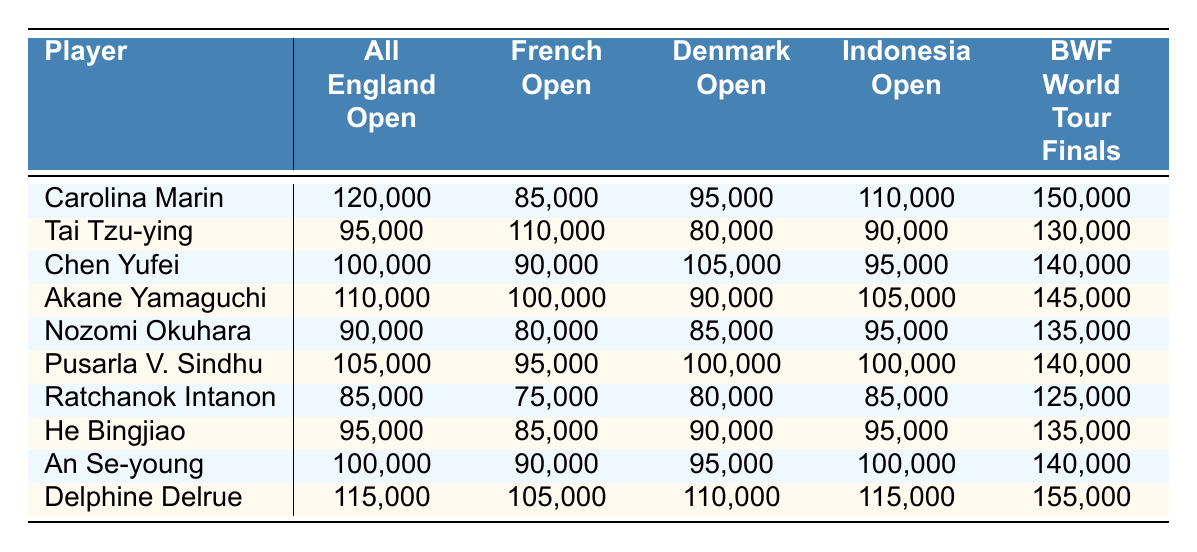What was the highest prize money earned by a single player at the All England Open? The All England Open prize money for each player is listed in the first column of the table. Carolina Marin earned the highest amount, which is 120,000.
Answer: 120,000 Who earned the lowest prize money at the French Open? The French Open prize money is shown in the second column. Ratchanok Intanon earned the least with 75,000.
Answer: 75,000 What is the total prize money earned by An Se-young across all tournaments listed? To find this, we sum An Se-young's prize amounts: 100,000 + 90,000 + 95,000 + 100,000 + 140,000 = 525,000.
Answer: 525,000 Did any player earn more than 140,000 at the BWF World Tour Finals? By checking the BWF World Tour Finals column, we can see that only Delphine Delrue earned 155,000, which is more than 140,000.
Answer: Yes Which player had the highest combined earnings across the All England Open and the Indonesia Open? Comparing the first and fourth columns, we find the sums: Carolina Marin (120,000 + 110,000 = 230,000), Akane Yamaguchi (110,000 + 105,000 = 215,000), and others. Carolina Marin has the highest sum of 230,000.
Answer: Carolina Marin What is the average prize money for Pusarla V. Sindhu across all tournaments? Pusarla V. Sindhu's prize money is 105,000 + 95,000 + 100,000 + 100,000 + 140,000 = 540,000. The average is 540,000 / 5 = 108,000.
Answer: 108,000 Is the sum of prize money from the Denmark Open for the top three players more than 300,000? Summing the Denmark Open amounts for Carolina Marin (95,000), Tai Tzu-ying (80,000), and Chen Yufei (105,000) gives 280,000, which is less than 300,000.
Answer: No Who has the highest total prize money across the tournaments listed in the table? Calculating the sums reveals that Delphine Delrue (115,000 + 105,000 + 110,000 + 115,000 + 155,000 = 600,000) has the highest total earnings.
Answer: Delphine Delrue Did Akane Yamaguchi earn more at the European Championships than at the Japan Open? Akane Yamaguchi earned 60,000 at the European Championships and 100,000 at the Japan Open, making her Japan Open earnings higher.
Answer: No Which player has a consistent earning pattern with no amount lower than 90,000? Analyzing all players, we see that only Carolina Marin has no amount lower than 90,000 across all tournaments.
Answer: Carolina Marin 